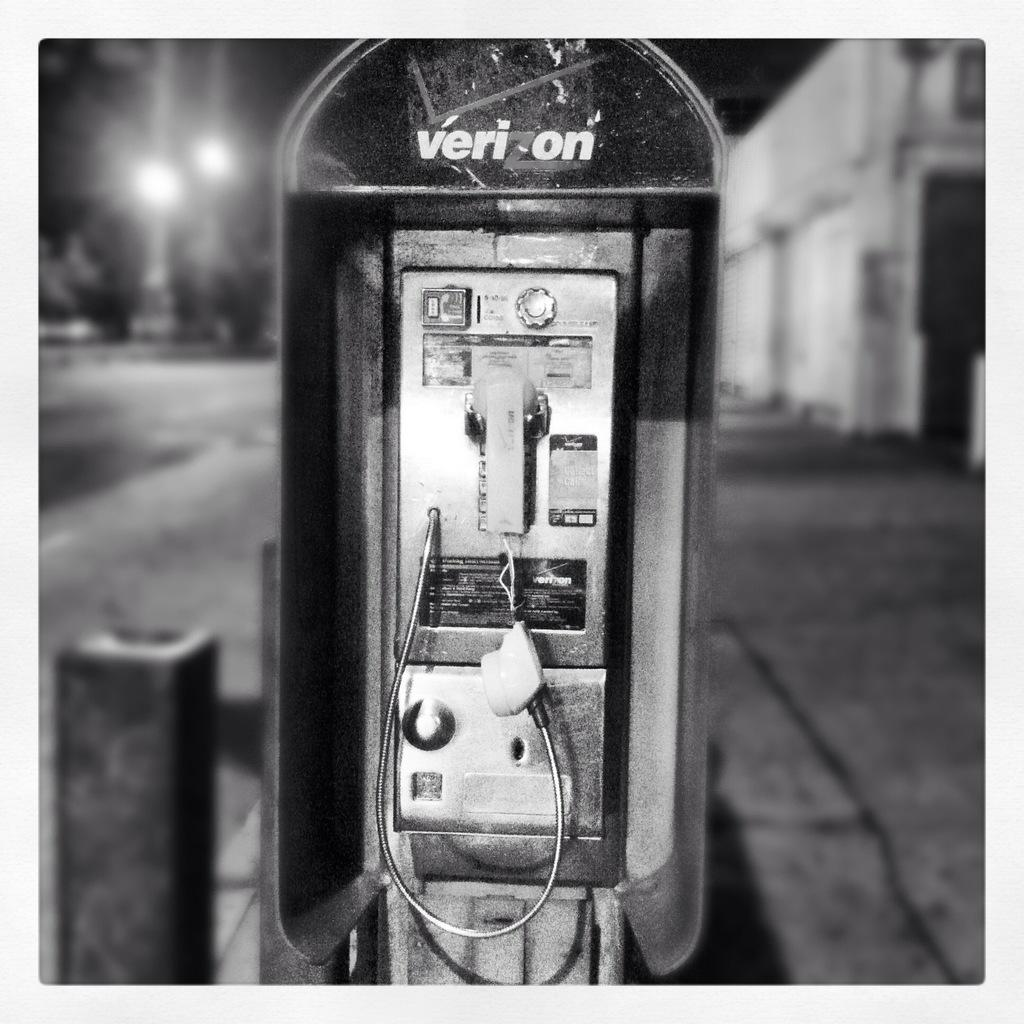Provide a one-sentence caption for the provided image. A battered and abused public phone is adorned with the Verizon logo. 